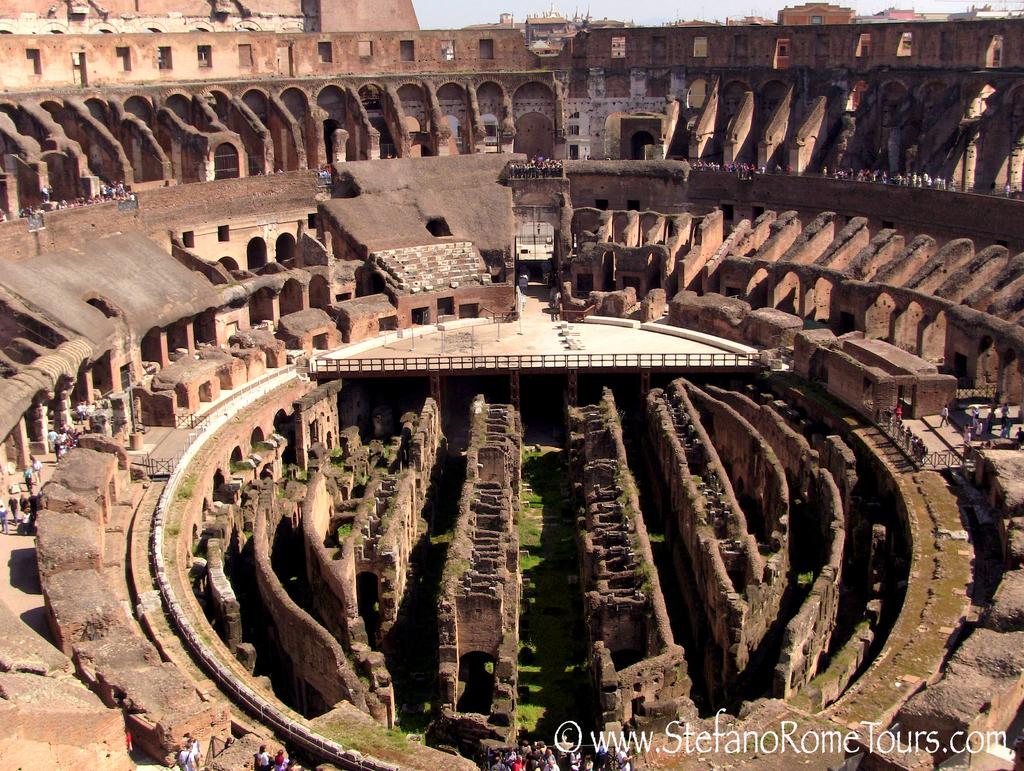What famous landmark is featured in the picture? There is a Colosseum in the picture. What type of terrain surrounds the landmark? Grass is visible on the ground. Are there any people in the image? Yes, there are people visible in the image. Where is the text located in the image? The text is in the bottom right corner of the image. How far away is the cherry tree from the Colosseum in the image? There is no cherry tree present in the image, so it is not possible to determine the distance between it and the Colosseum. 